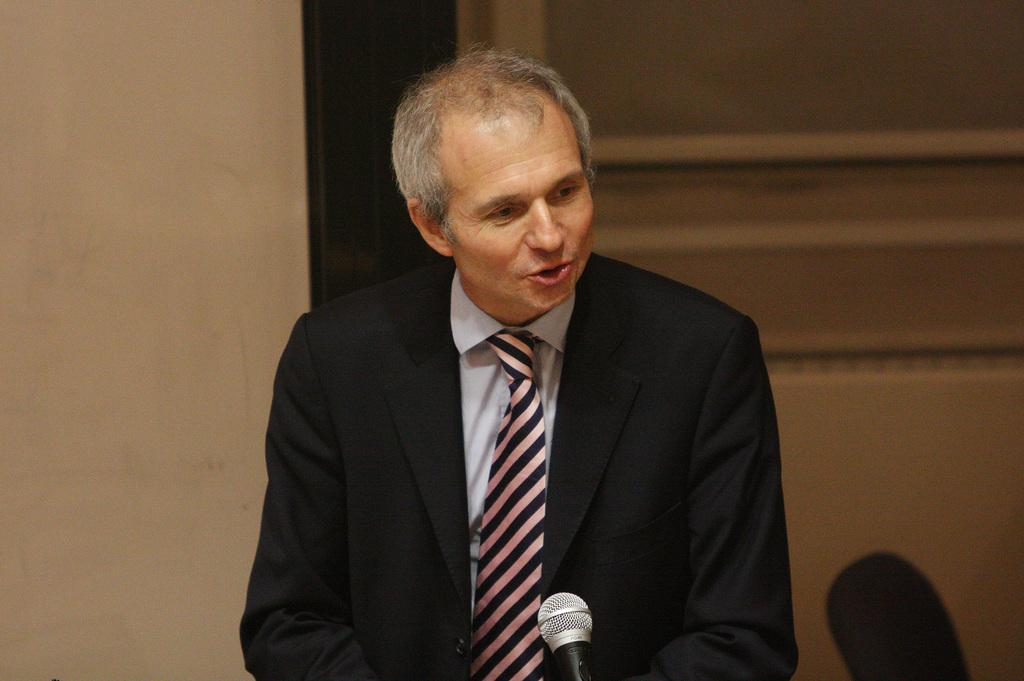Who is the main subject in the image? There is a person in the center of the image. What is the person wearing? The person is wearing a coat and a tie. What object is visible in the image that is commonly used for speaking or performing? There is a microphone (mic) in the image. What can be seen in the background of the image? There is a chair and a wall in the background of the image. How many dolls are sitting on the ship in the image? There are no dolls or ships present in the image. What suggestion does the person in the image have for the audience? The image does not provide any information about a suggestion or an audience, so we cannot answer this question. 